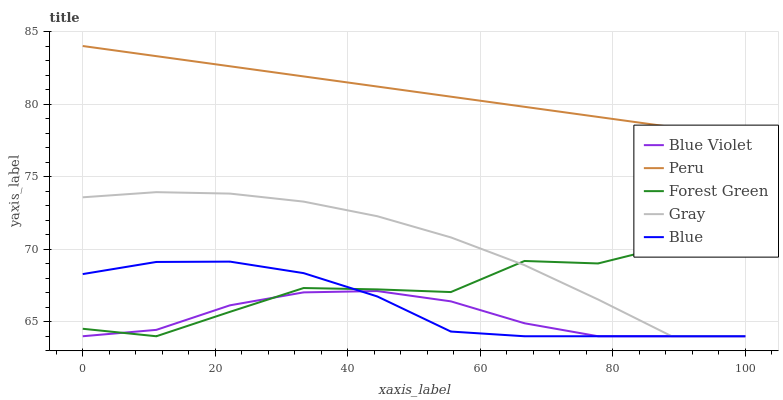Does Gray have the minimum area under the curve?
Answer yes or no. No. Does Gray have the maximum area under the curve?
Answer yes or no. No. Is Gray the smoothest?
Answer yes or no. No. Is Gray the roughest?
Answer yes or no. No. Does Peru have the lowest value?
Answer yes or no. No. Does Gray have the highest value?
Answer yes or no. No. Is Blue Violet less than Peru?
Answer yes or no. Yes. Is Peru greater than Blue Violet?
Answer yes or no. Yes. Does Blue Violet intersect Peru?
Answer yes or no. No. 